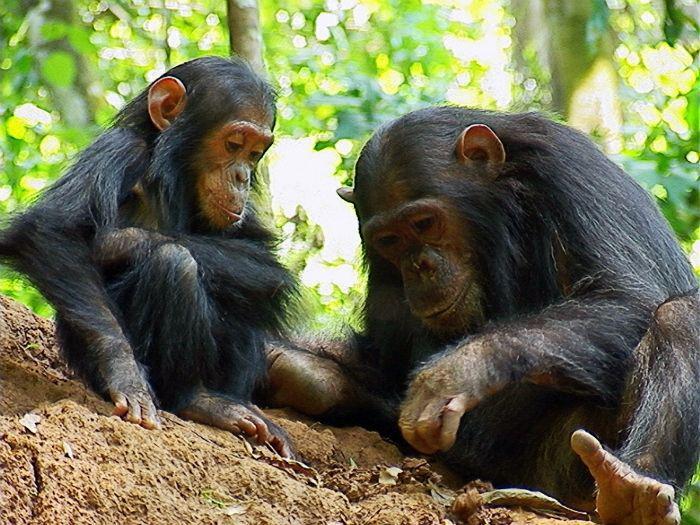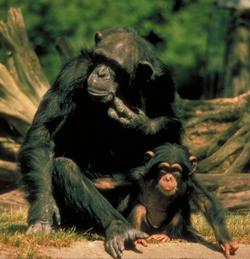The first image is the image on the left, the second image is the image on the right. Assess this claim about the two images: "In one image, a person is interacting with a chimpanzee, while a second image shows a chimp sitting with its knees drawn up and arms resting on them.". Correct or not? Answer yes or no. No. The first image is the image on the left, the second image is the image on the right. For the images shown, is this caption "An image contains a human interacting with a chimpanzee." true? Answer yes or no. No. 